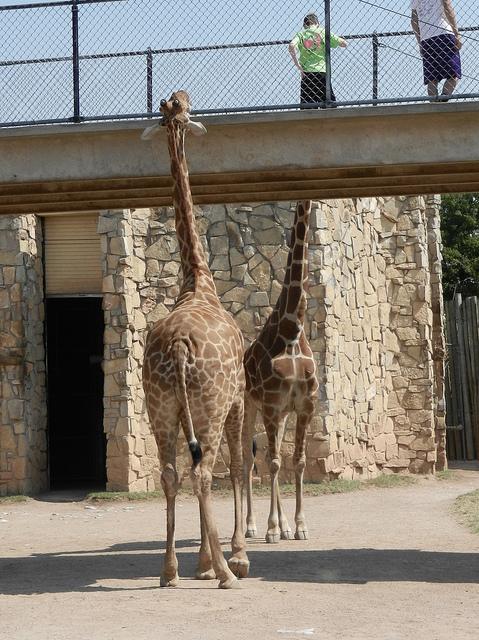Are there more than two giraffe in this picture?
Answer briefly. No. What animals are in the picture?
Be succinct. Giraffes. Are the giraffes friends or foes?
Be succinct. Friends. 